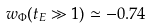Convert formula to latex. <formula><loc_0><loc_0><loc_500><loc_500>w _ { \Phi } ( t _ { E } \gg 1 ) \simeq - 0 . 7 4</formula> 